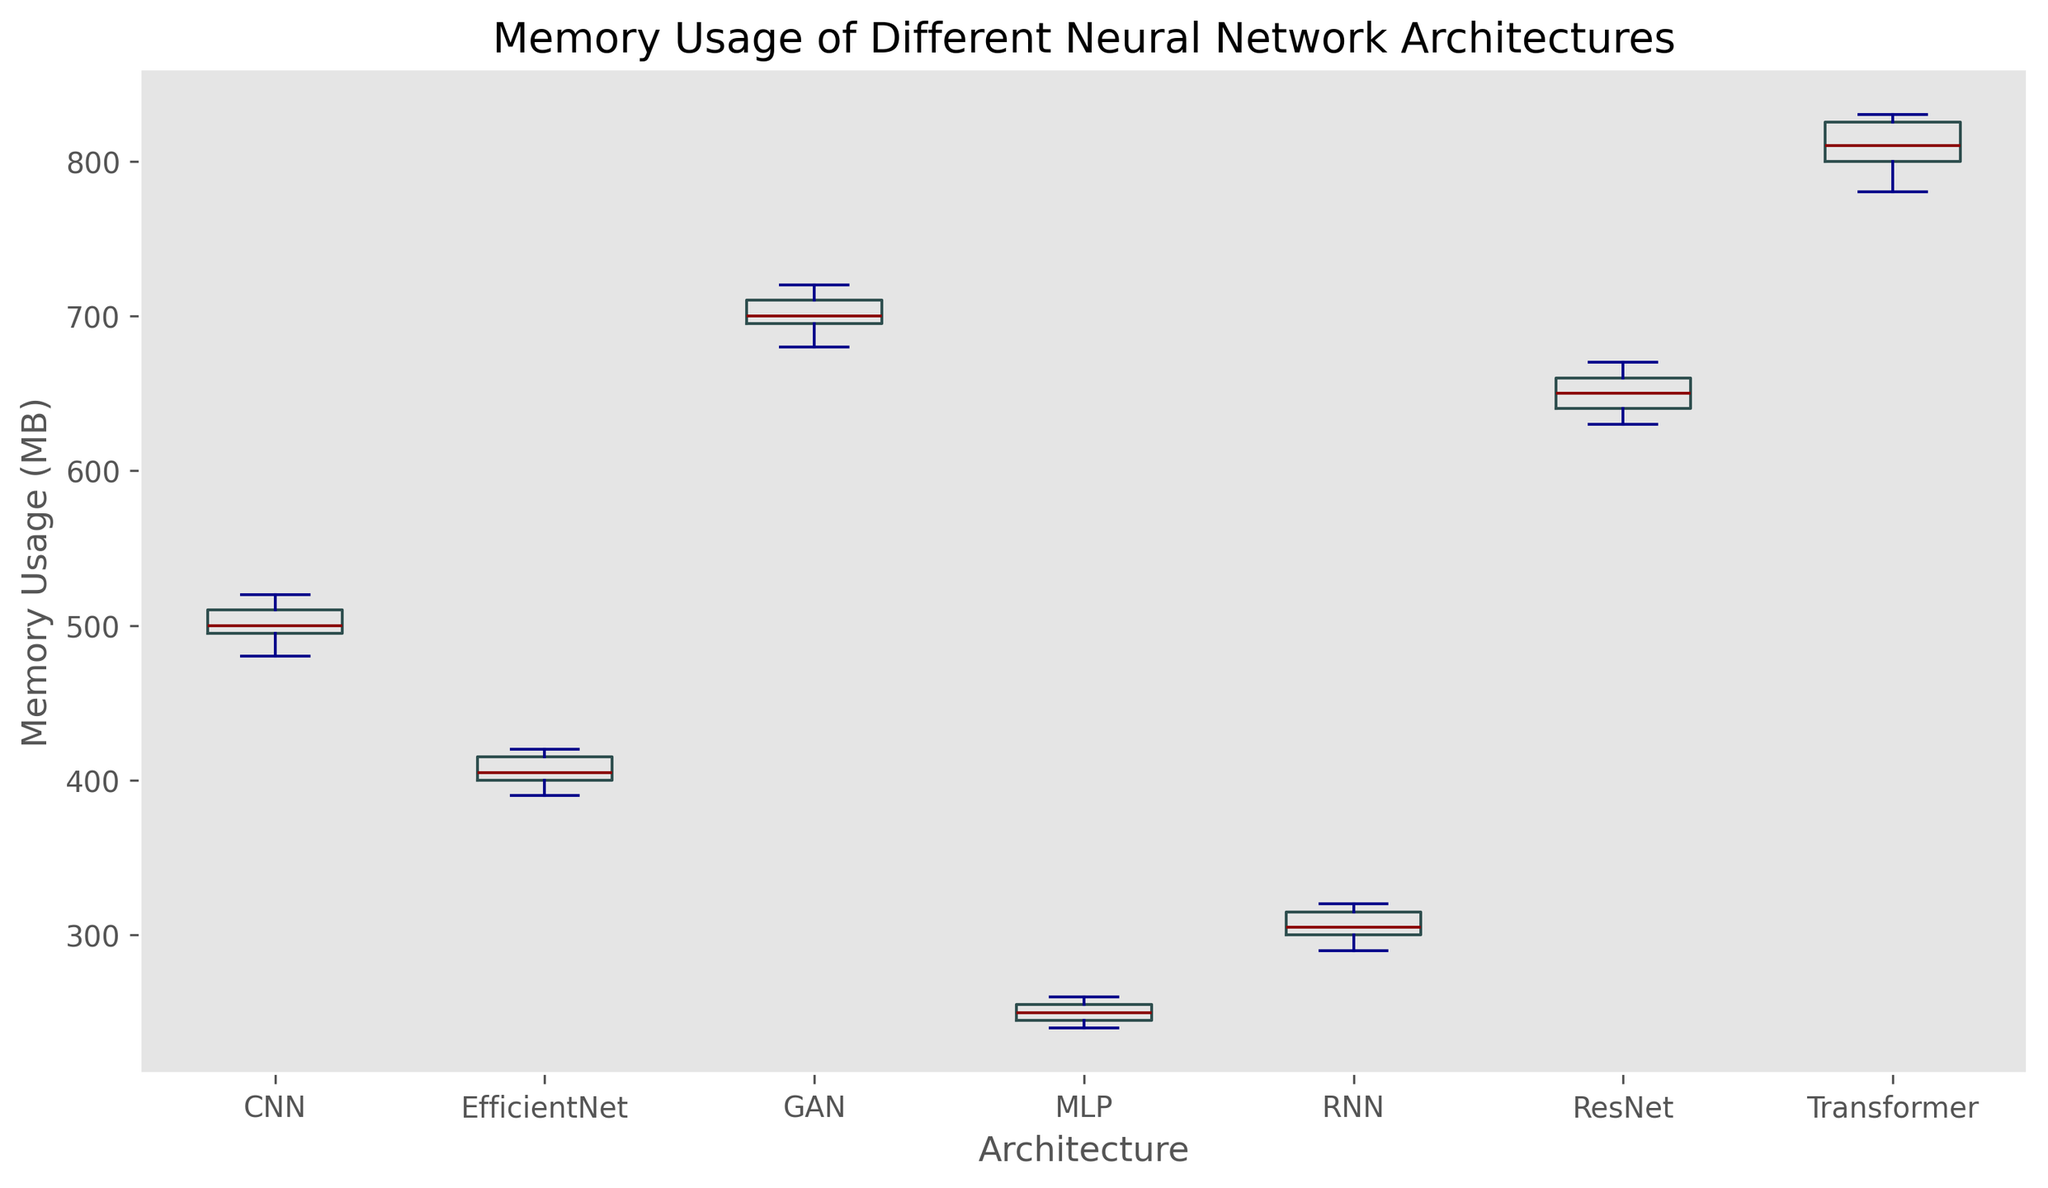What's the median memory usage of the Transformer architecture? First, look at the box plot for the Transformer architecture. The median is indicated by the line inside the box.
Answer: 810 MB Which architecture has the highest median memory usage? Compare the median lines of all the architectures' box plots. The Transformer architecture has the highest median.
Answer: Transformer What is the interquartile range (IQR) of the ResNet architecture's memory usage? The interquartile range (IQR) is the distance between the upper quartile (top of the box) and lower quartile (bottom of the box). For ResNet, these values are 670 MB (upper quartile) and 640 MB (lower quartile). Subtract the lower quartile from the upper quartile: 670 - 640 = 30 MB.
Answer: 30 MB Which architecture has the lowest maximum value of memory usage? Look for the topmost point of the whiskers for all architectures. The MLP architecture has the lowest maximum value (260 MB).
Answer: MLP What is the range of memory usage values for CNN architecture? The range is found by subtracting the minimum value from the maximum value. From the plot, the maximum value for CNN is 520 MB and the minimum is 480 MB. So, 520 - 480 = 40 MB.
Answer: 40 MB Which architectures have an outlier? Outliers are indicated by points outside the whiskers. In this plot, there are no points outside the whiskers for any architecture.
Answer: None Rank the architectures from highest to lowest based on their median memory usage. Look at the median lines for each architecture on the box plot and rank them in order.
Answer: Transformer, GAN, ResNet, CNN, EfficientNet, RNN, MLP How does the memory usage variation of EfficientNet compare to that of RNN? Compare the lengths of the boxes and whiskers for EfficientNet and RNN. EfficientNet has a slightly larger IQR and whisker length compared to RNN, indicating a slightly higher variation in memory usage.
Answer: Slightly higher Which architecture shows the most variability in memory usage? Variability is indicated by the length of the box (IQR) and whiskers. The Transformer architecture has the longest combined length of box and whiskers, indicating the most variability.
Answer: Transformer 